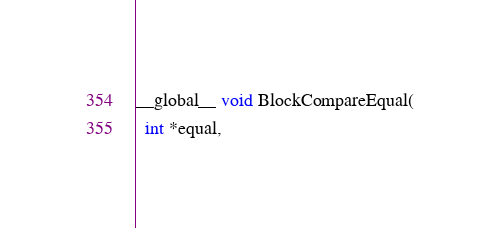Convert code to text. <code><loc_0><loc_0><loc_500><loc_500><_C_>__global__ void BlockCompareEqual(
  int *equal, </code> 